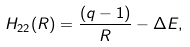Convert formula to latex. <formula><loc_0><loc_0><loc_500><loc_500>H _ { 2 2 } ( R ) = \frac { ( q - 1 ) } { R } - \Delta E ,</formula> 